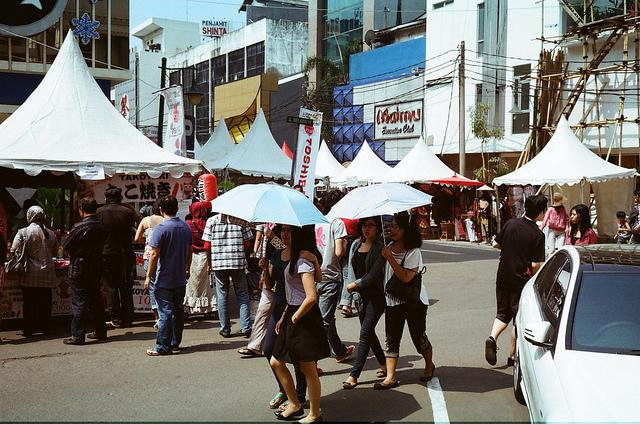Why are the people carrying umbrellas?

Choices:
A) blocking rain
B) blocking sun
C) to dance
D) to sell blocking sun 